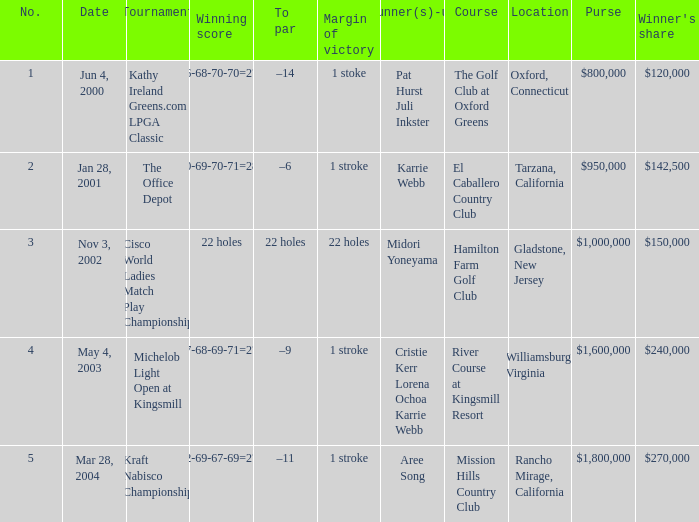Where was the tournament dated nov 3, 2002? Cisco World Ladies Match Play Championship. 